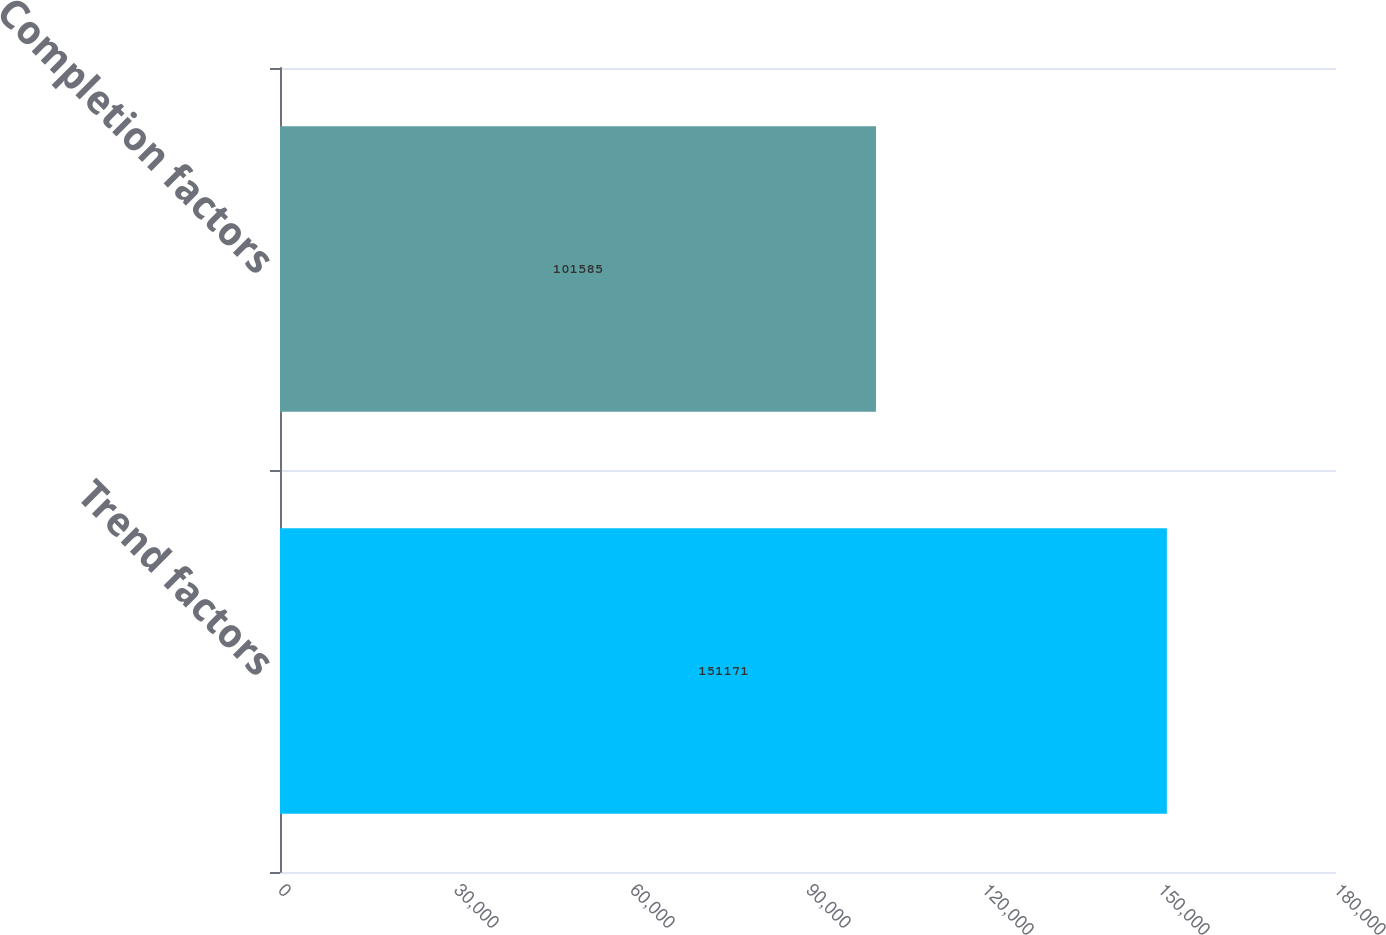<chart> <loc_0><loc_0><loc_500><loc_500><bar_chart><fcel>Trend factors<fcel>Completion factors<nl><fcel>151171<fcel>101585<nl></chart> 